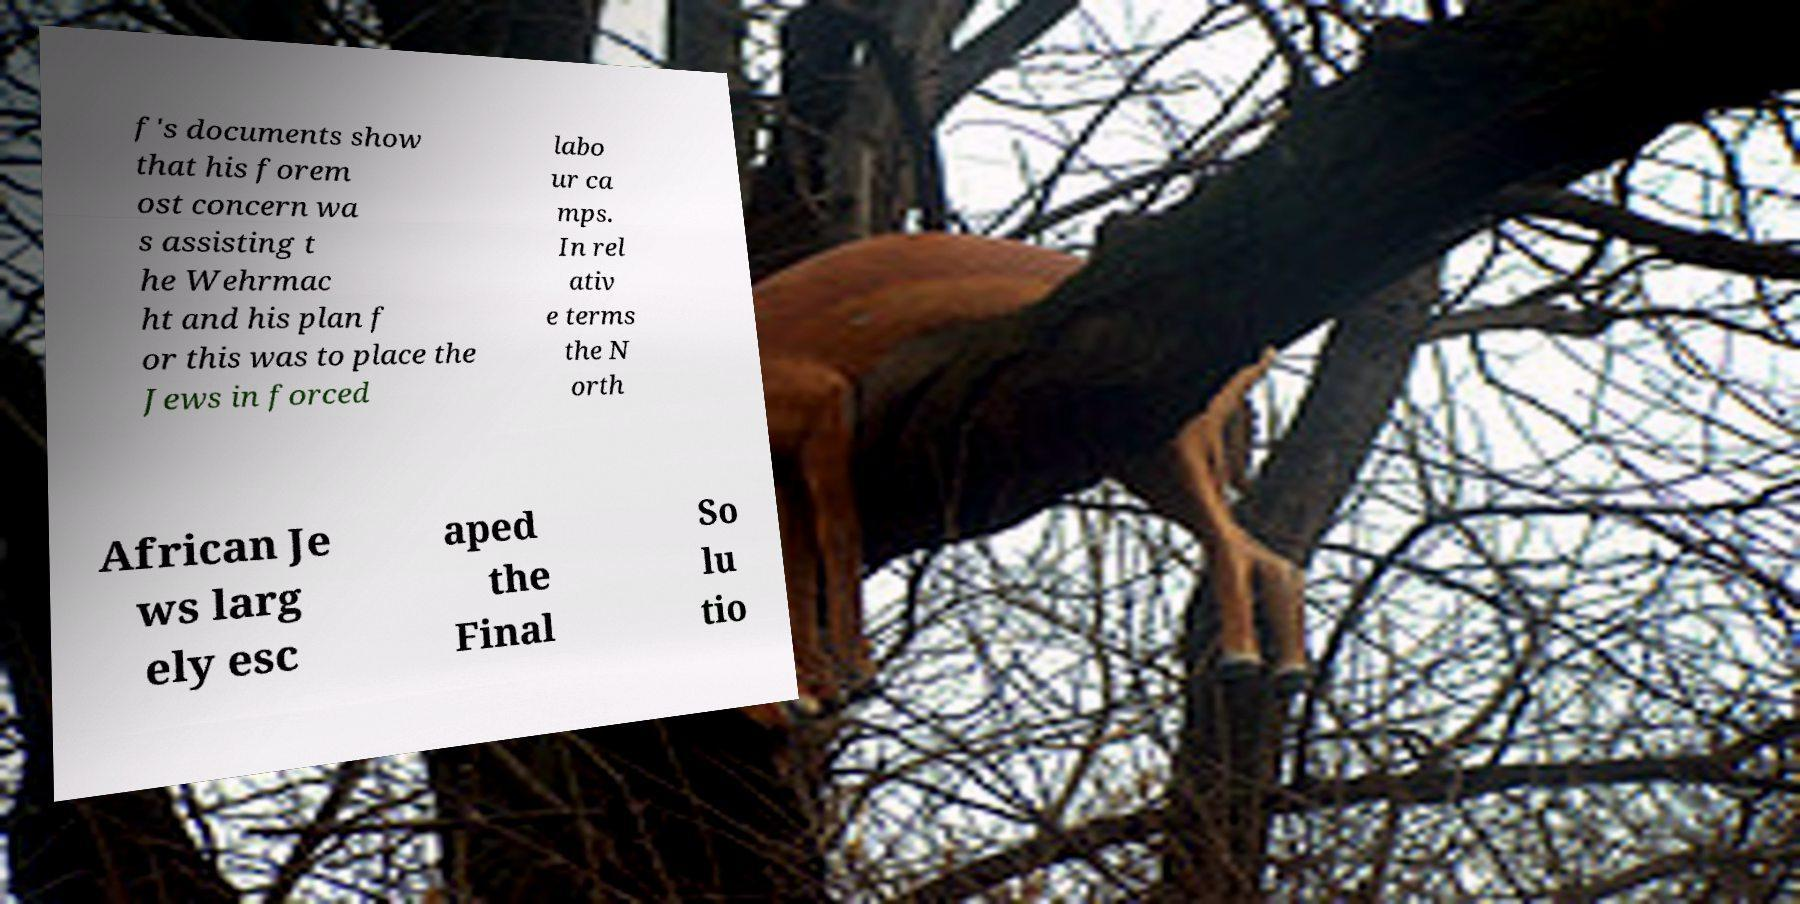Could you extract and type out the text from this image? f's documents show that his forem ost concern wa s assisting t he Wehrmac ht and his plan f or this was to place the Jews in forced labo ur ca mps. In rel ativ e terms the N orth African Je ws larg ely esc aped the Final So lu tio 